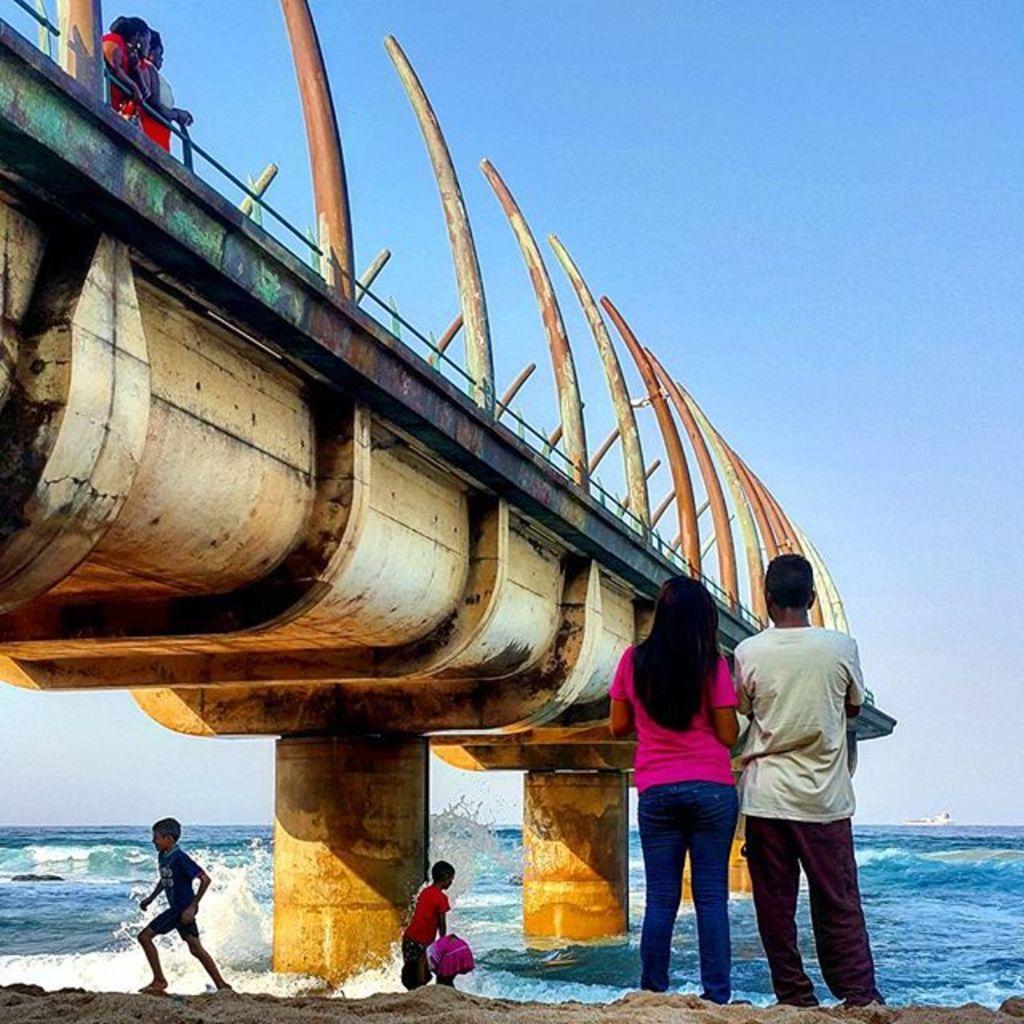Can you describe this image briefly? In this image I can see a bridge visible on the sea, in front of the sea I can see three children's and I can see two persons visible on the right side and at the top of the bridge I can see two persons standing in front of the fence. At the top I can see the sky. 